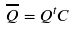<formula> <loc_0><loc_0><loc_500><loc_500>\overline { Q } = Q ^ { t } C</formula> 